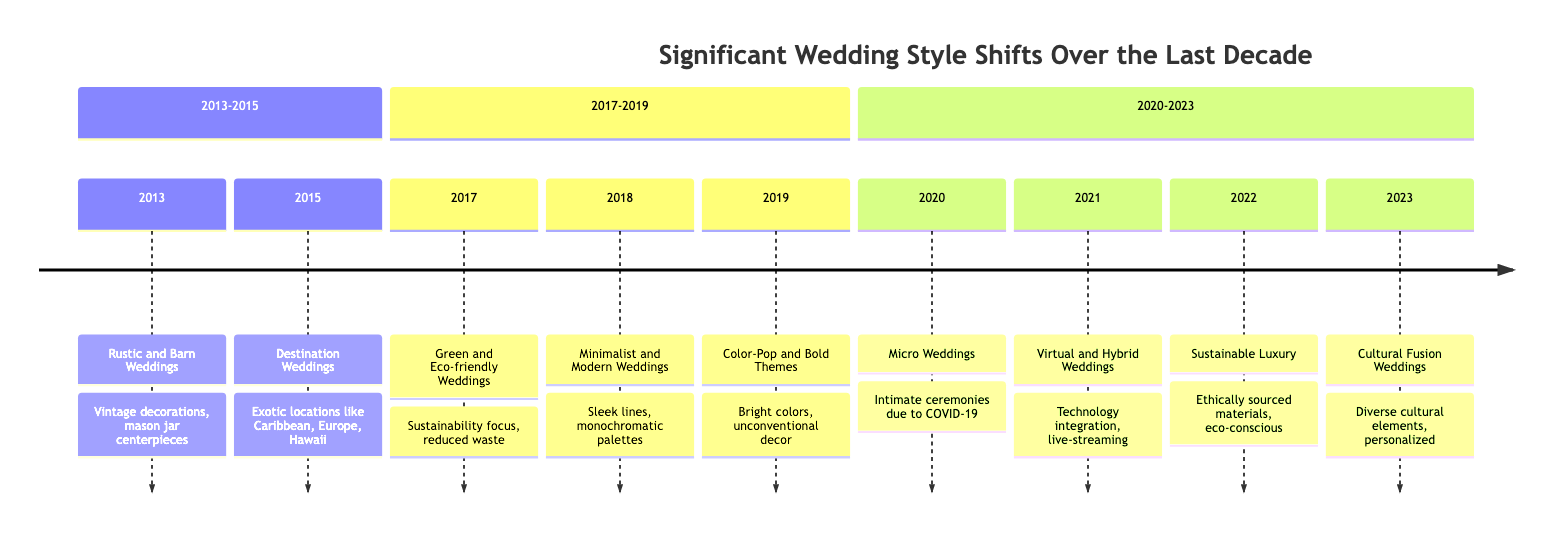What wedding style was popular in 2013? The diagram specifies that in 2013, "Rustic and Barn Weddings" were popular, characterized by vintage decorations, mason jar centerpieces, and barn venues.
Answer: Rustic and Barn Weddings How many significant wedding styles are listed in the timeline? By counting the timeline elements from 2013 to 2023, there are nine distinct significant wedding styles, each representing a trend for a specific year.
Answer: 9 Which wedding style emphasizes sustainability? The timeline indicates that "Green and Eco-friendly Weddings," introduced in 2017, focused on sustainability with eco-friendly decorations, local sourcing, and reduced waste.
Answer: Green and Eco-friendly Weddings What year did "Micro Weddings" become a trend? According to the timeline, "Micro Weddings" were a trend that emerged in 2020, particularly due to the impact of the COVID-19 pandemic leading to intimate ceremonies.
Answer: 2020 Between which years did "Minimalist and Modern Weddings" gain popularity? The diagram shows that "Minimalist and Modern Weddings" became a trend in 2018, with no style listed for the years before that up until 2019, indicating a focus on that specific year.
Answer: 2018 What is a key feature of "Cultural Fusion Weddings"? The timeline describes "Cultural Fusion Weddings" introduced in 2023, which incorporates diverse cultural elements and traditions, creating unique and personalized ceremonies.
Answer: Diverse cultural elements Which wedding event exemplifies "Sustainable Luxury"? The timeline lists "Brooklyn Beckham and Nicola Peltz's Eco-Luxury Wedding" as an example of the "Sustainable Luxury" trend that emerged in 2022, blending luxury with sustainability.
Answer: Brooklyn Beckham and Nicola Peltz's Eco-Luxury Wedding What significant trend occurred in 2021? The timeline highlights "Virtual and Hybrid Weddings" as a significant trend in 2021, showcasing the integration of technology and live-streamed ceremonies allowing virtual participation.
Answer: Virtual and Hybrid Weddings What was a notable feature of weddings in 2019? The "Color-Pop and Bold Themes" trend was noted for its bright, bold colors and unconventional decor choices that became dominant in 2019.
Answer: Bright, bold colors 